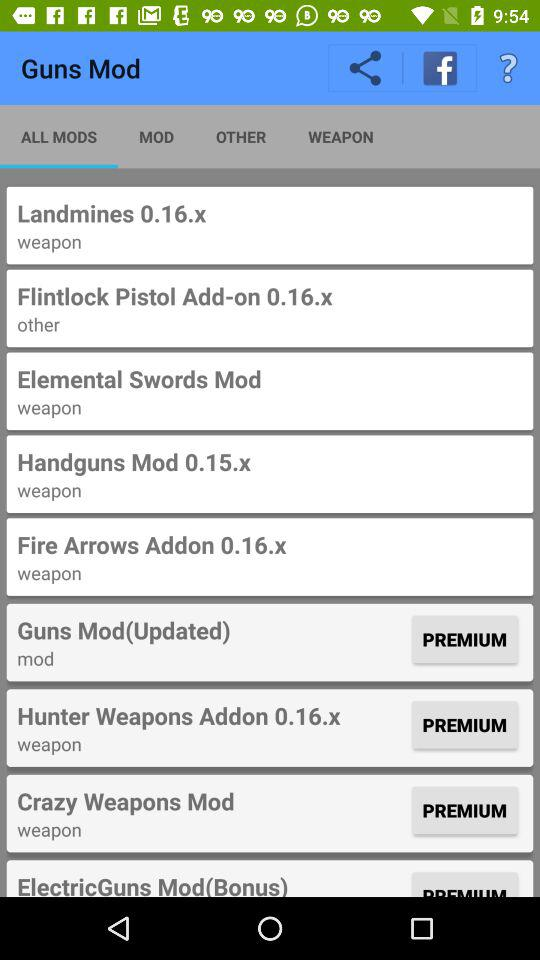What is the application name? The application name is "Guns Mod". 